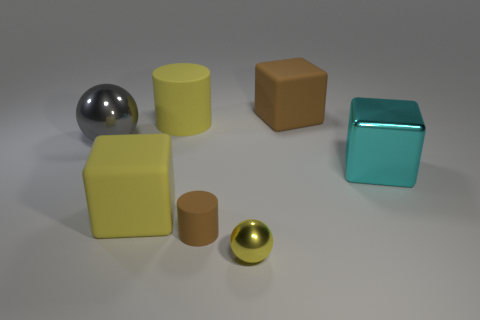Add 2 balls. How many objects exist? 9 Subtract all cylinders. How many objects are left? 5 Subtract 1 brown cubes. How many objects are left? 6 Subtract all cyan shiny cubes. Subtract all tiny brown shiny cylinders. How many objects are left? 6 Add 4 cylinders. How many cylinders are left? 6 Add 2 big cyan shiny things. How many big cyan shiny things exist? 3 